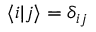Convert formula to latex. <formula><loc_0><loc_0><loc_500><loc_500>\langle i | j \rangle = \delta _ { i j }</formula> 